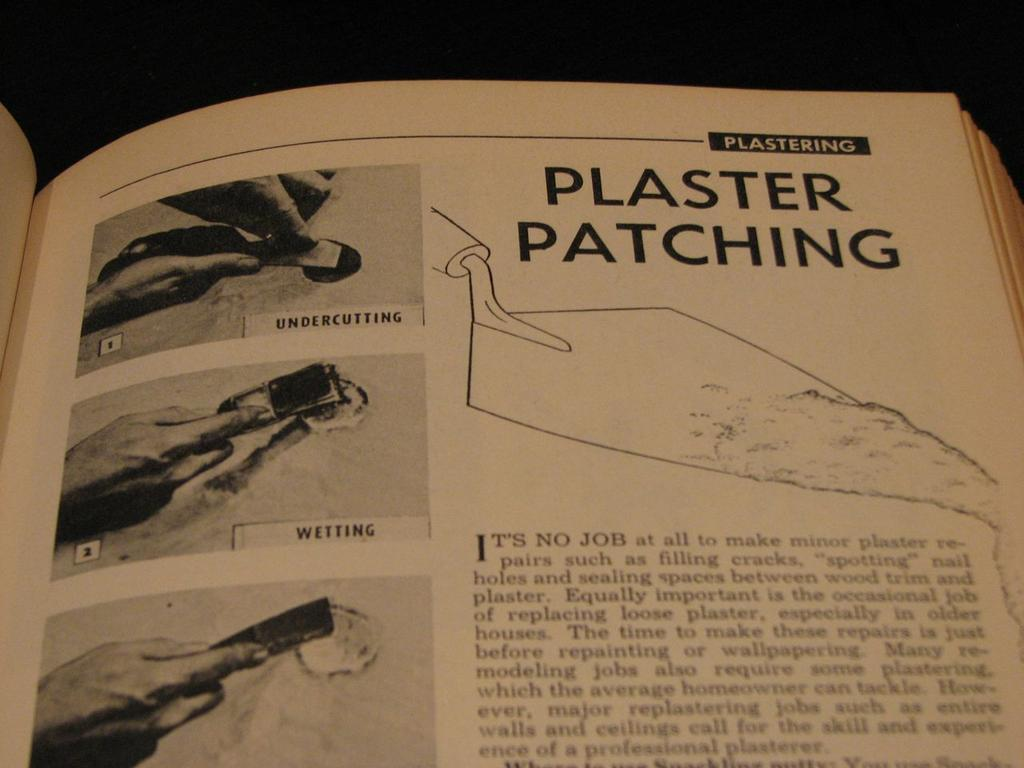<image>
Render a clear and concise summary of the photo. A book on Plastering that is open to a page called Plaster Patching 